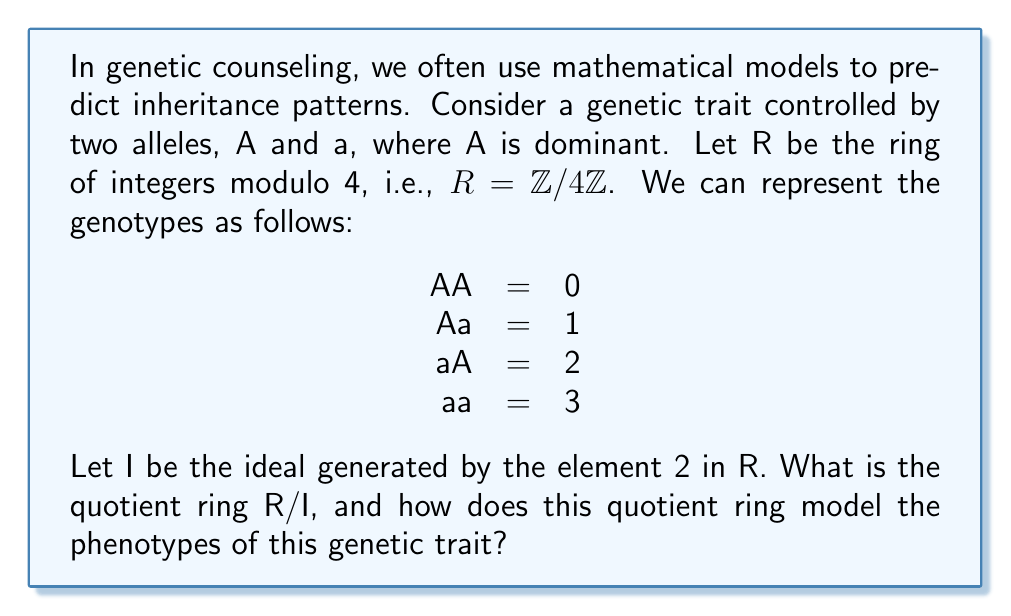Give your solution to this math problem. To solve this problem, we need to follow these steps:

1) First, let's understand what the ideal I = (2) means in R = $\mathbb{Z}/4\mathbb{Z}$:
   I = {0, 2} (because 2 + 2 ≡ 0 (mod 4))

2) The quotient ring R/I will have cosets of the form:
   [0] = {0, 2}
   [1] = {1, 3}

3) This means R/I has two elements, which we can represent as:
   R/I = {[0], [1]}

4) The operation in R/I is addition modulo 2, which makes R/I isomorphic to $\mathbb{Z}/2\mathbb{Z}$.

5) Now, let's interpret this in terms of genetics:
   - [0] represents the coset containing AA (0) and aa (3)
   - [1] represents the coset containing Aa (1) and aA (2)

6) In terms of phenotypes:
   - [0] represents both homozygous genotypes (AA and aa)
   - [1] represents the heterozygous genotypes (Aa and aA)

7) Since A is dominant, the phenotypes are:
   - [0] includes both AA (dominant phenotype) and aa (recessive phenotype)
   - [1] represents Aa and aA, both of which show the dominant phenotype

This quotient ring models the phenotypes by grouping genotypes that can potentially show different phenotypes ([0]), and those that will always show the same phenotype ([1]).
Answer: The quotient ring R/I is isomorphic to $\mathbb{Z}/2\mathbb{Z}$. It models the phenotypes by grouping AA and aa (which can show different phenotypes) into [0], and Aa and aA (which always show the dominant phenotype) into [1]. 